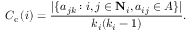Convert formula to latex. <formula><loc_0><loc_0><loc_500><loc_500>C _ { c } \left ( i \right ) = \frac { | \{ a _ { j k } \colon i , j \in { N } _ { i } , a _ { i j } \in A \} | } { k _ { i } ( k _ { i } - 1 ) } .</formula> 